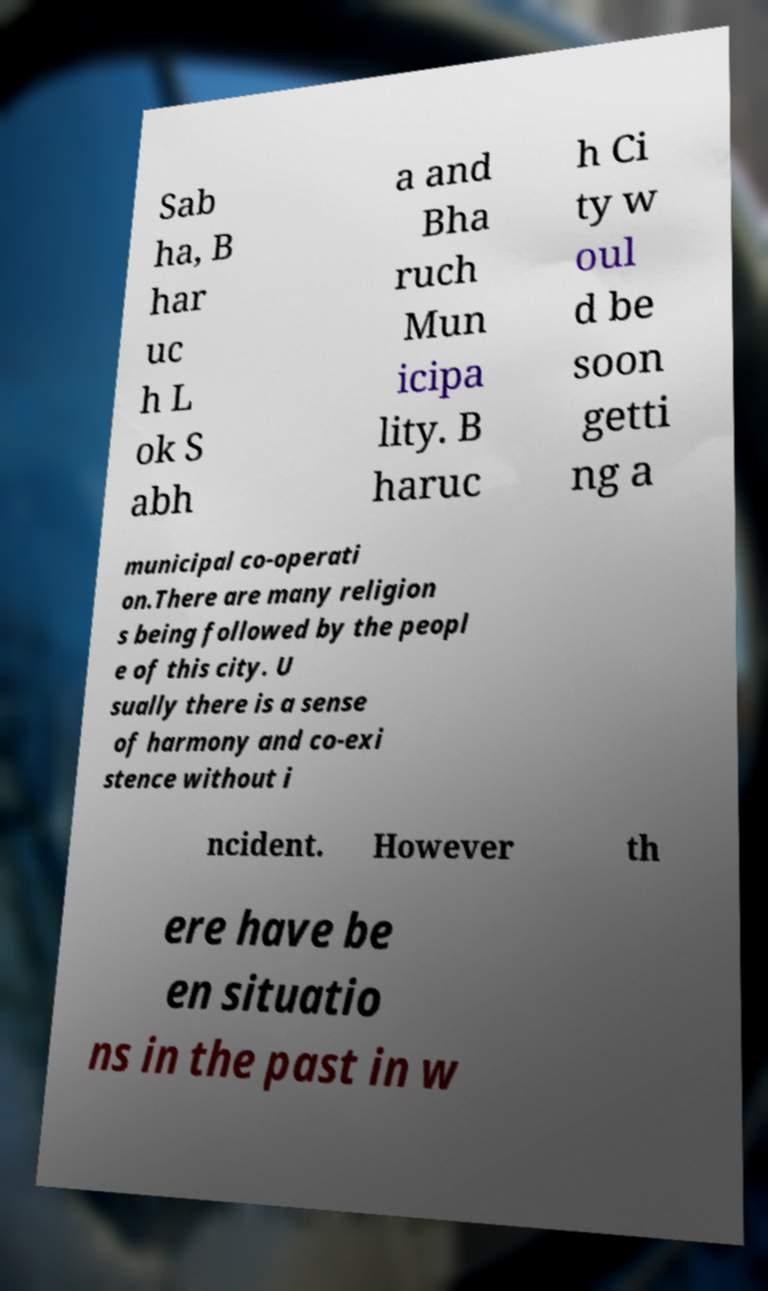I need the written content from this picture converted into text. Can you do that? Sab ha, B har uc h L ok S abh a and Bha ruch Mun icipa lity. B haruc h Ci ty w oul d be soon getti ng a municipal co-operati on.There are many religion s being followed by the peopl e of this city. U sually there is a sense of harmony and co-exi stence without i ncident. However th ere have be en situatio ns in the past in w 